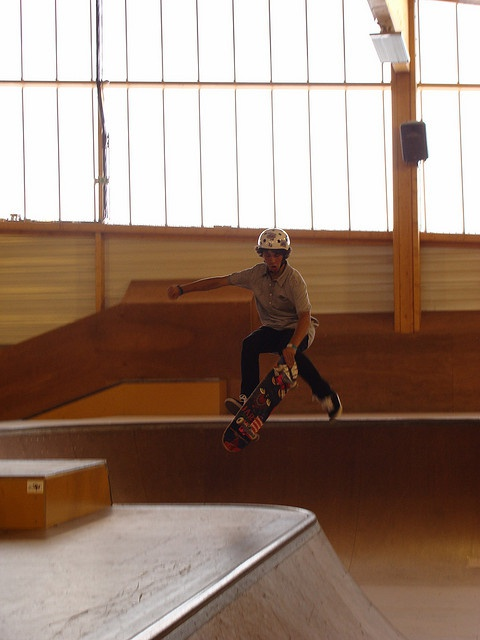Describe the objects in this image and their specific colors. I can see people in white, black, maroon, and gray tones and skateboard in white, black, maroon, and brown tones in this image. 